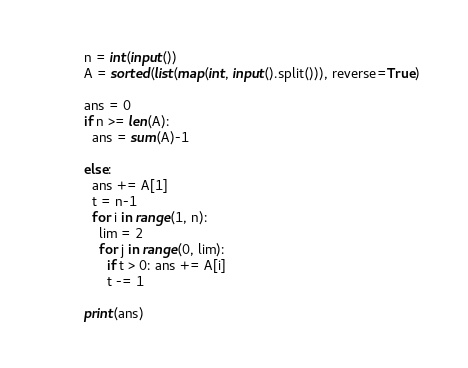<code> <loc_0><loc_0><loc_500><loc_500><_Python_>n = int(input())
A = sorted(list(map(int, input().split())), reverse=True)

ans = 0
if n >= len(A):
  ans = sum(A)-1
  
else:
  ans += A[1]
  t = n-1
  for i in range(1, n):
    lim = 2
    for j in range(0, lim):
      if t > 0: ans += A[i]
      t -= 1
      
print(ans)
</code> 